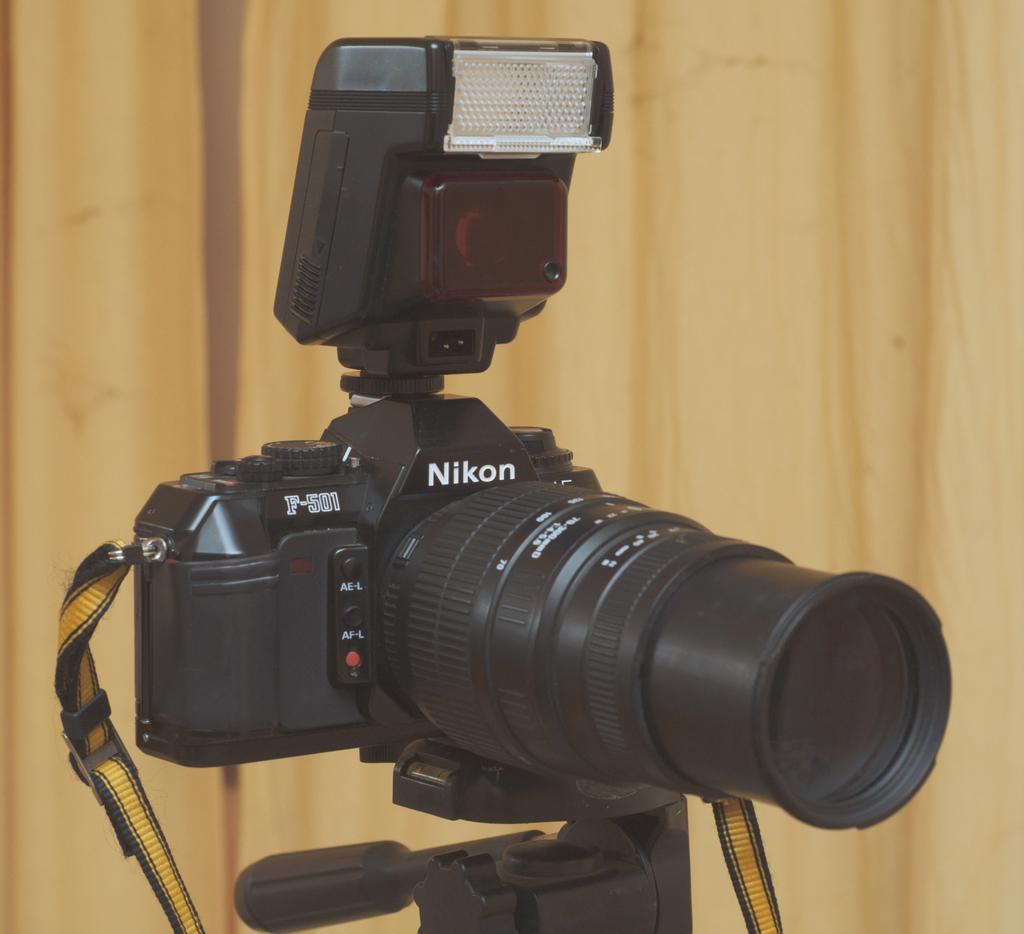Describe this image in one or two sentences. In the center of the picture we can see a camera on the stand. In the background it is looking like a wall. 